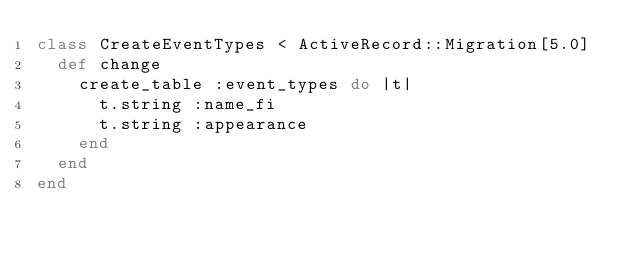Convert code to text. <code><loc_0><loc_0><loc_500><loc_500><_Ruby_>class CreateEventTypes < ActiveRecord::Migration[5.0]
  def change
    create_table :event_types do |t|
      t.string :name_fi
      t.string :appearance
    end
  end
end
</code> 